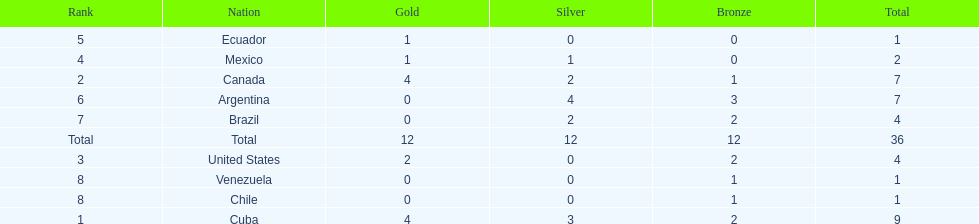How many total medals did argentina win? 7. 